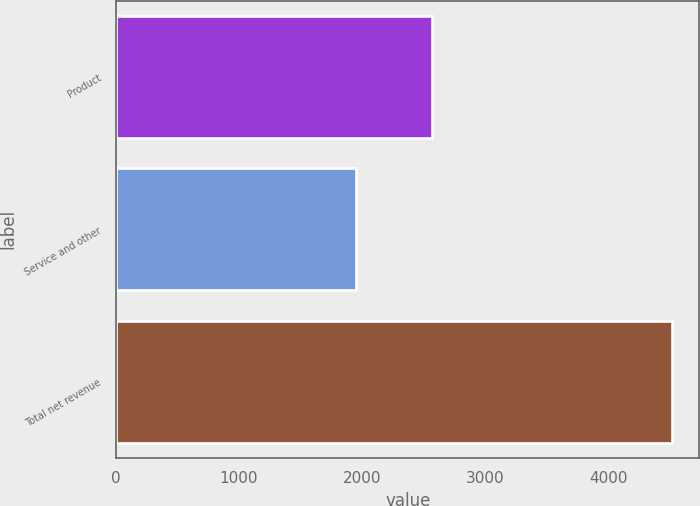<chart> <loc_0><loc_0><loc_500><loc_500><bar_chart><fcel>Product<fcel>Service and other<fcel>Total net revenue<nl><fcel>2568<fcel>1947<fcel>4515<nl></chart> 